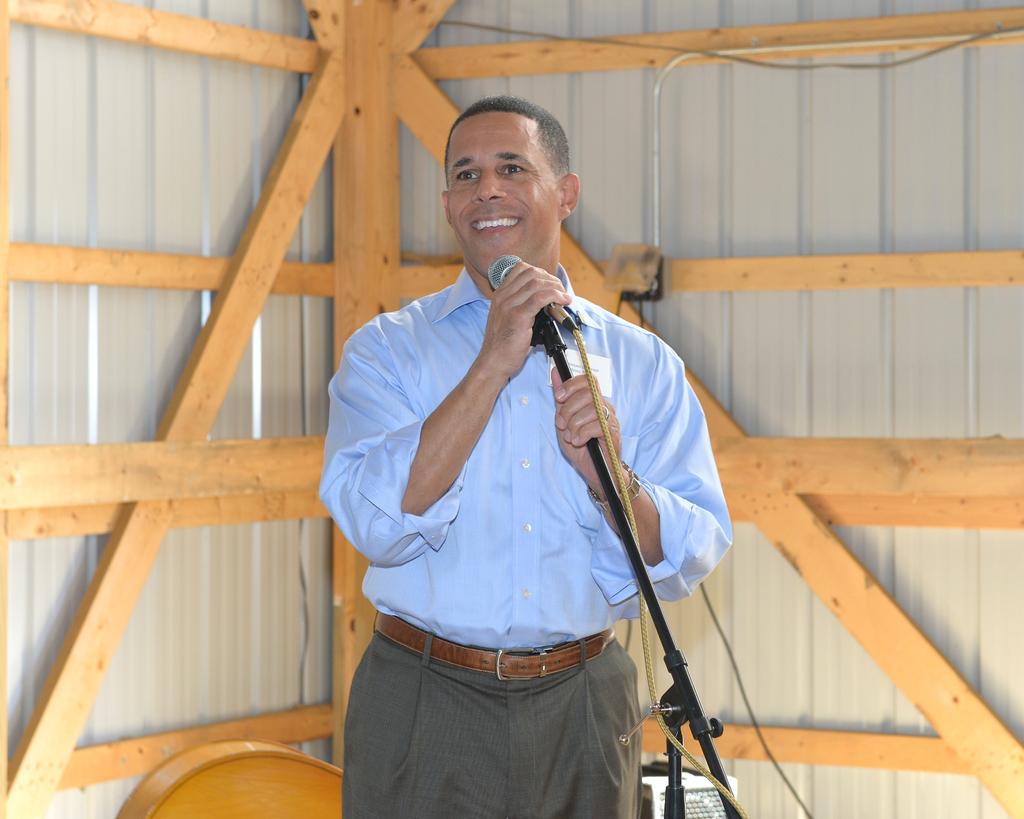Could you give a brief overview of what you see in this image? In this image we can see a person wearing shirt is holding a mic with stand, is standing and smiling. In the background, we can see wooden frames and the wall. 